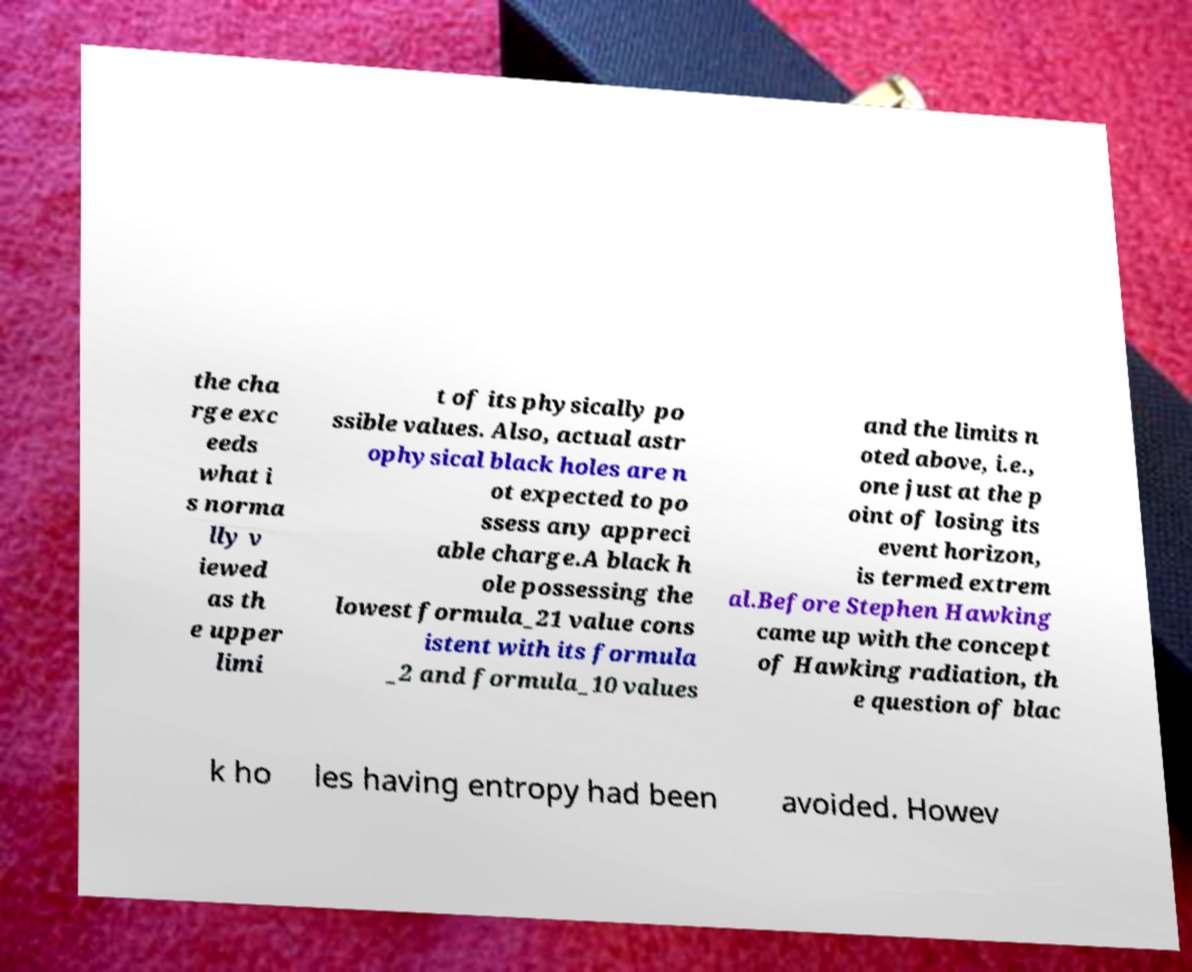What messages or text are displayed in this image? I need them in a readable, typed format. the cha rge exc eeds what i s norma lly v iewed as th e upper limi t of its physically po ssible values. Also, actual astr ophysical black holes are n ot expected to po ssess any appreci able charge.A black h ole possessing the lowest formula_21 value cons istent with its formula _2 and formula_10 values and the limits n oted above, i.e., one just at the p oint of losing its event horizon, is termed extrem al.Before Stephen Hawking came up with the concept of Hawking radiation, th e question of blac k ho les having entropy had been avoided. Howev 